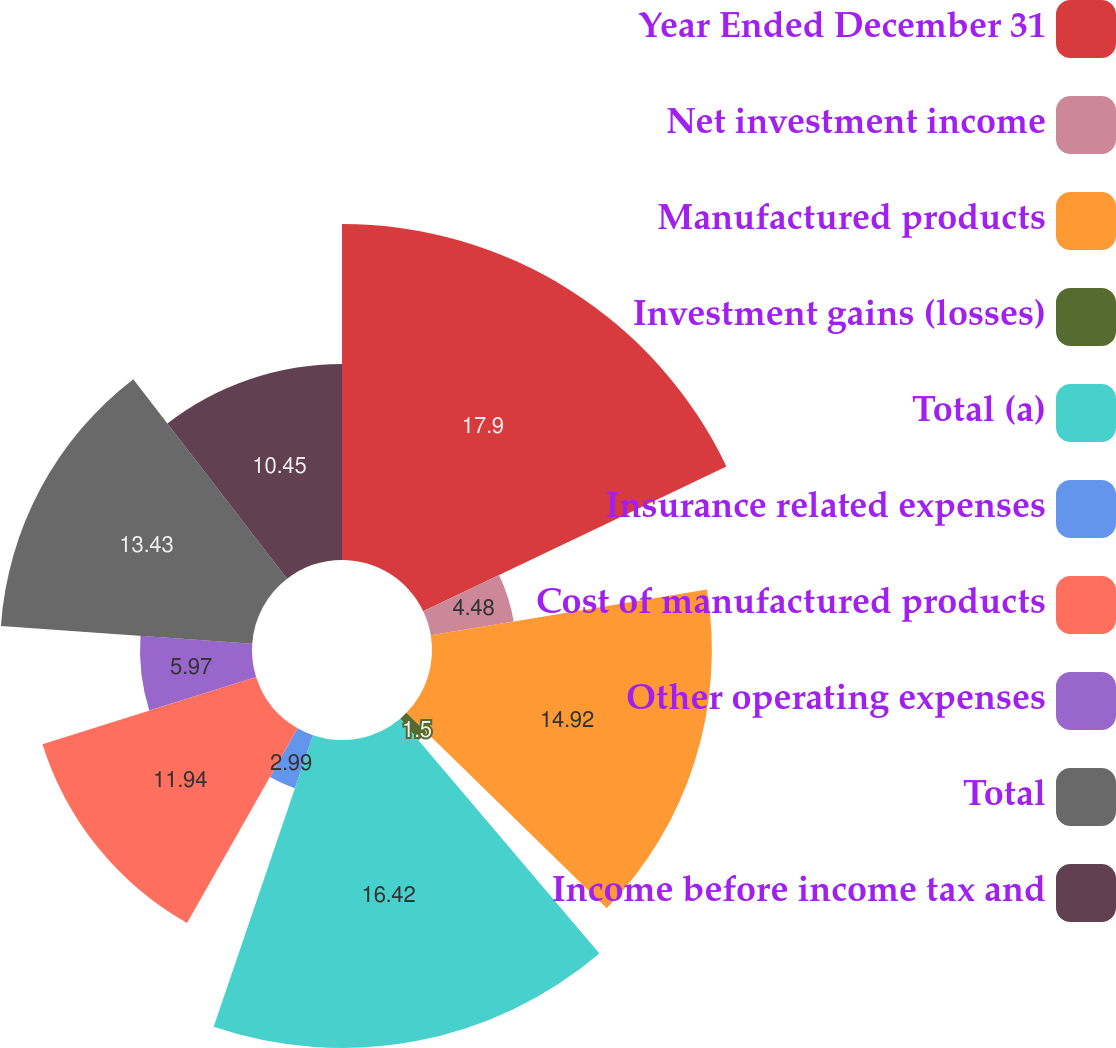Convert chart. <chart><loc_0><loc_0><loc_500><loc_500><pie_chart><fcel>Year Ended December 31<fcel>Net investment income<fcel>Manufactured products<fcel>Investment gains (losses)<fcel>Total (a)<fcel>Insurance related expenses<fcel>Cost of manufactured products<fcel>Other operating expenses<fcel>Total<fcel>Income before income tax and<nl><fcel>17.91%<fcel>4.48%<fcel>14.92%<fcel>1.5%<fcel>16.42%<fcel>2.99%<fcel>11.94%<fcel>5.97%<fcel>13.43%<fcel>10.45%<nl></chart> 